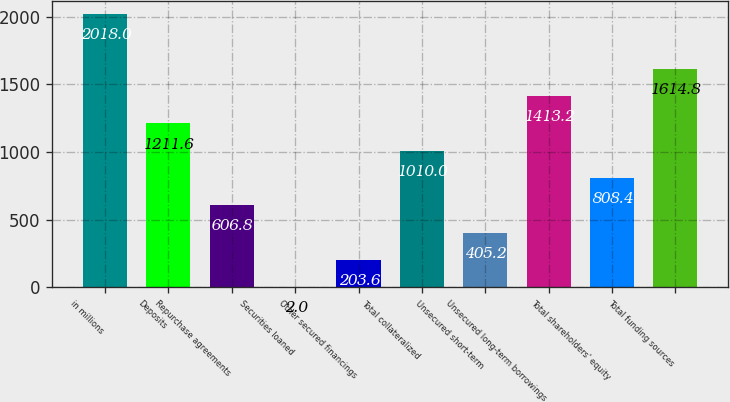Convert chart. <chart><loc_0><loc_0><loc_500><loc_500><bar_chart><fcel>in millions<fcel>Deposits<fcel>Repurchase agreements<fcel>Securities loaned<fcel>Other secured financings<fcel>Total collateralized<fcel>Unsecured short-term<fcel>Unsecured long-term borrowings<fcel>Total shareholders' equity<fcel>Total funding sources<nl><fcel>2018<fcel>1211.6<fcel>606.8<fcel>2<fcel>203.6<fcel>1010<fcel>405.2<fcel>1413.2<fcel>808.4<fcel>1614.8<nl></chart> 